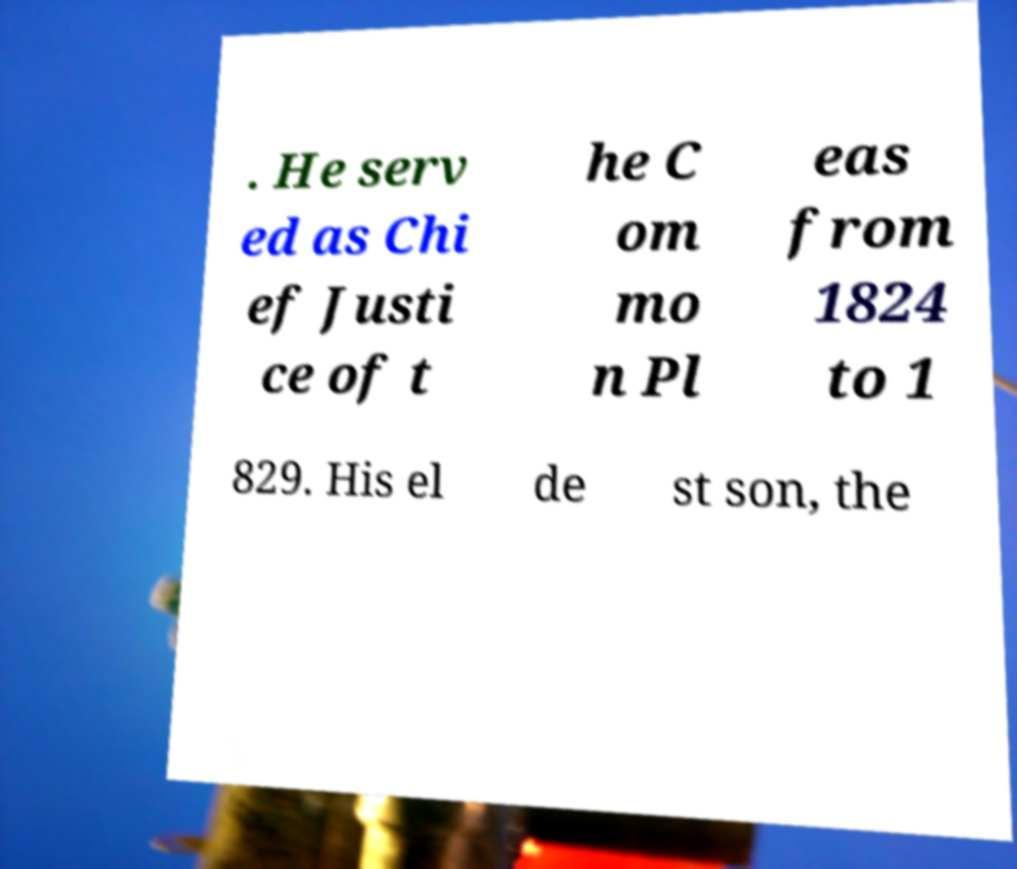What messages or text are displayed in this image? I need them in a readable, typed format. . He serv ed as Chi ef Justi ce of t he C om mo n Pl eas from 1824 to 1 829. His el de st son, the 